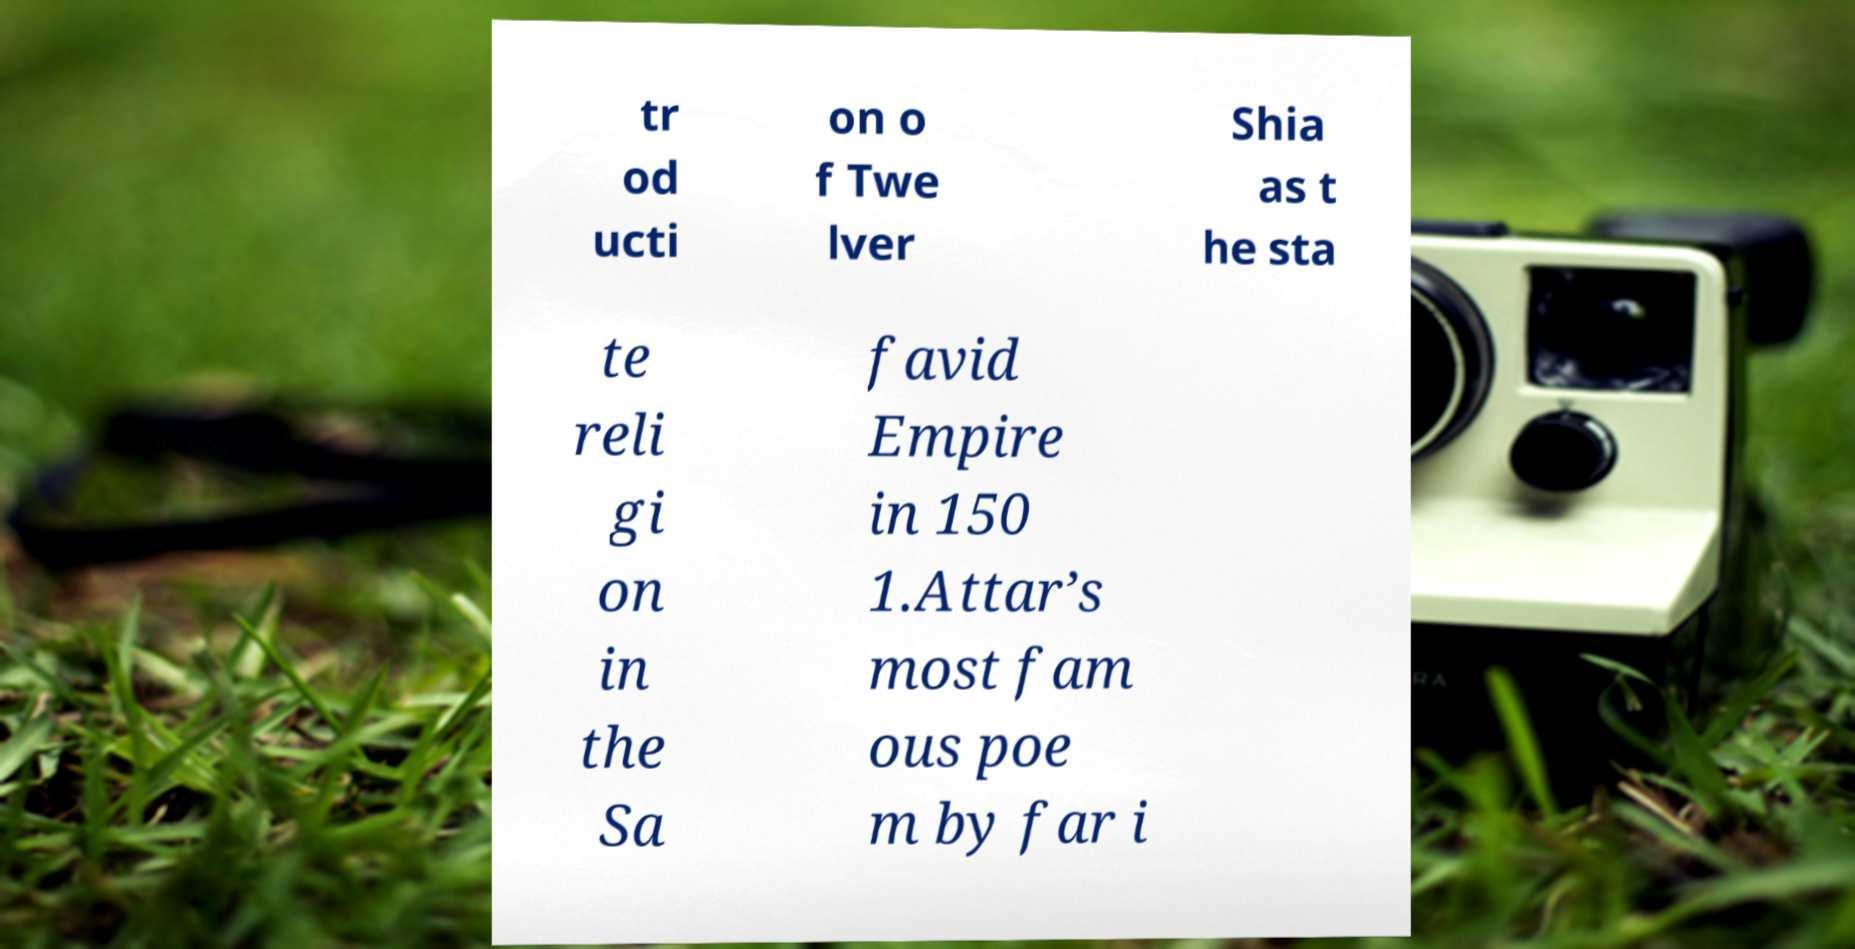What messages or text are displayed in this image? I need them in a readable, typed format. tr od ucti on o f Twe lver Shia as t he sta te reli gi on in the Sa favid Empire in 150 1.Attar’s most fam ous poe m by far i 